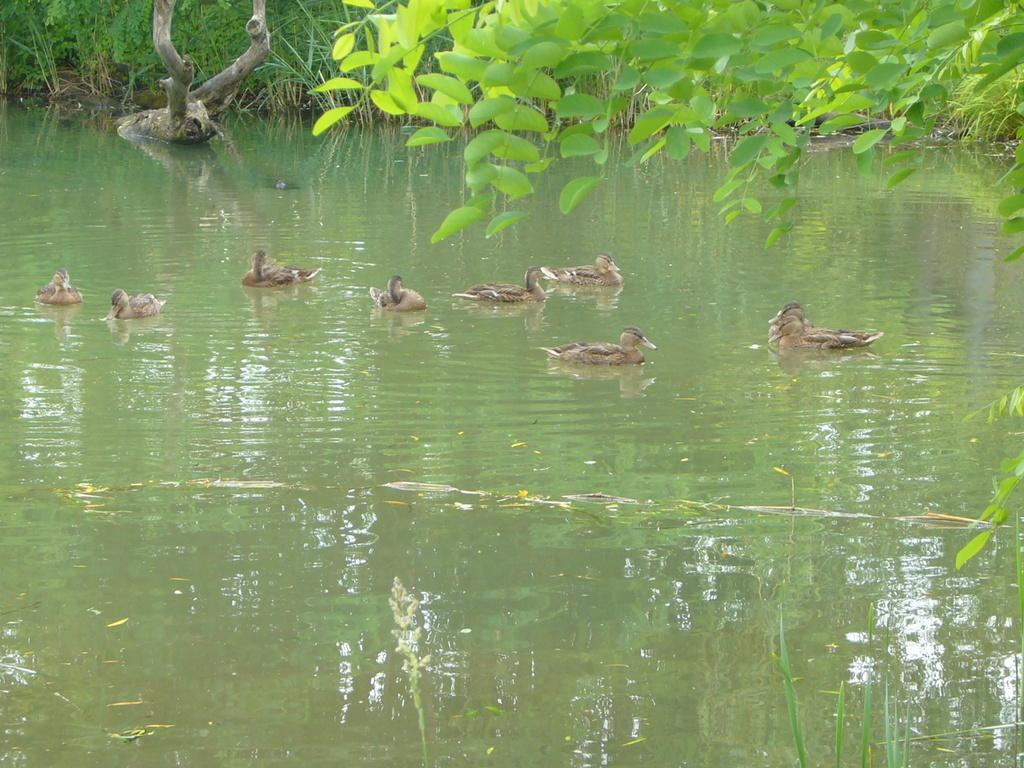What type of animals can be seen on the water in the image? There are ducks on the water in the image. What type of vegetation is visible in the image? Leaves and grass are present in the image. What else can be seen in the image besides the ducks and vegetation? Branches are present in the image. How many toes can be seen on the ducks in the image? There are no visible toes on the ducks in the image, as they are not visible in the water. 